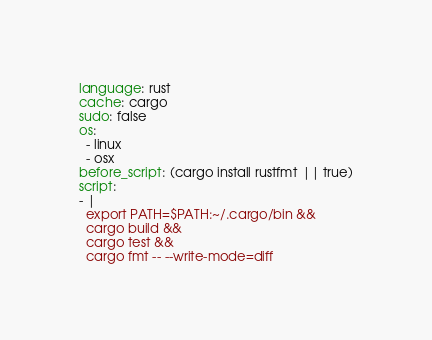Convert code to text. <code><loc_0><loc_0><loc_500><loc_500><_YAML_>language: rust
cache: cargo
sudo: false
os:
  - linux
  - osx
before_script: (cargo install rustfmt || true)
script:
- |
  export PATH=$PATH:~/.cargo/bin &&
  cargo build &&
  cargo test &&
  cargo fmt -- --write-mode=diff
</code> 